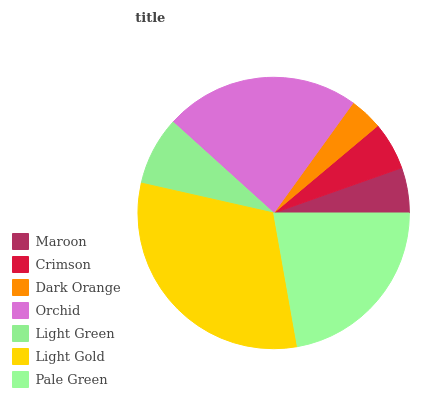Is Dark Orange the minimum?
Answer yes or no. Yes. Is Light Gold the maximum?
Answer yes or no. Yes. Is Crimson the minimum?
Answer yes or no. No. Is Crimson the maximum?
Answer yes or no. No. Is Crimson greater than Maroon?
Answer yes or no. Yes. Is Maroon less than Crimson?
Answer yes or no. Yes. Is Maroon greater than Crimson?
Answer yes or no. No. Is Crimson less than Maroon?
Answer yes or no. No. Is Light Green the high median?
Answer yes or no. Yes. Is Light Green the low median?
Answer yes or no. Yes. Is Crimson the high median?
Answer yes or no. No. Is Maroon the low median?
Answer yes or no. No. 